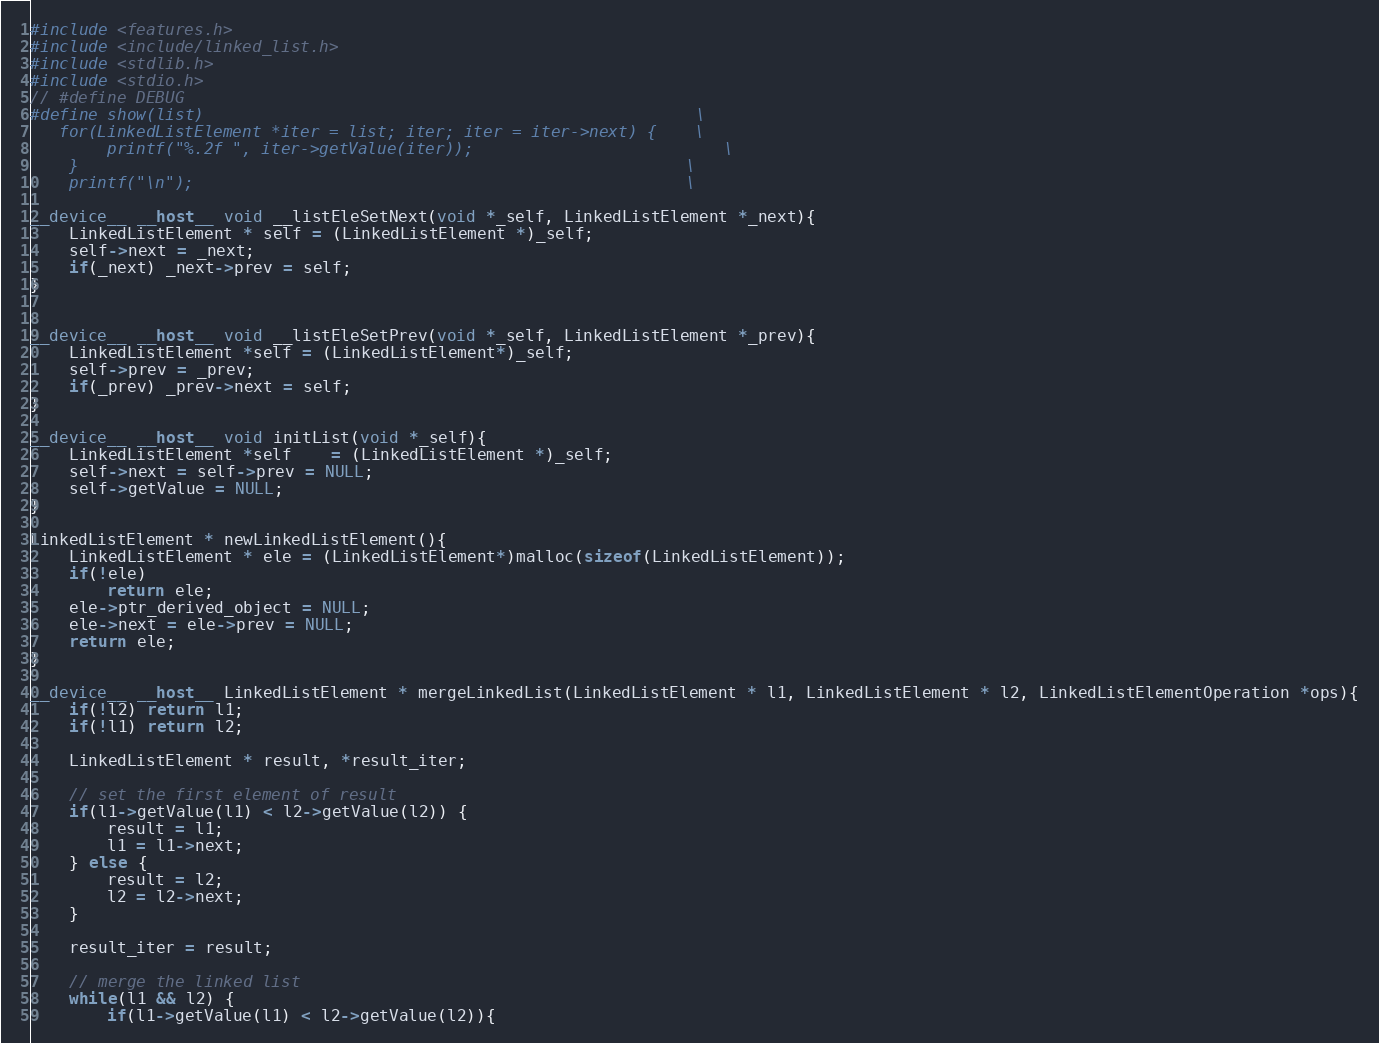Convert code to text. <code><loc_0><loc_0><loc_500><loc_500><_Cuda_>#include <features.h>
#include <include/linked_list.h>
#include <stdlib.h>
#include <stdio.h>
// #define DEBUG
#define show(list) 													\
   for(LinkedListElement *iter = list; iter; iter = iter->next) {    \
		printf("%.2f ", iter->getValue(iter));  						\
	}  																\
	printf("\n"); 													\

__device__ __host__ void __listEleSetNext(void *_self, LinkedListElement *_next){
	LinkedListElement * self = (LinkedListElement *)_self;	
	self->next = _next;
	if(_next) _next->prev = self;
}


__device__ __host__ void __listEleSetPrev(void *_self, LinkedListElement *_prev){
	LinkedListElement *self = (LinkedListElement*)_self;
	self->prev = _prev;
	if(_prev) _prev->next = self;
}

__device__ __host__ void initList(void *_self){
	LinkedListElement *self	= (LinkedListElement *)_self;
	self->next = self->prev = NULL;
	self->getValue = NULL;
}

LinkedListElement * newLinkedListElement(){
	LinkedListElement * ele = (LinkedListElement*)malloc(sizeof(LinkedListElement));
	if(!ele)
		return ele;
	ele->ptr_derived_object = NULL;
    ele->next = ele->prev = NULL;
	return ele;
}

__device__ __host__ LinkedListElement * mergeLinkedList(LinkedListElement * l1, LinkedListElement * l2, LinkedListElementOperation *ops){
	if(!l2) return l1;
	if(!l1) return l2;

	LinkedListElement * result, *result_iter;
	
	// set the first element of result
	if(l1->getValue(l1) < l2->getValue(l2)) {
		result = l1;
		l1 = l1->next;
	} else {
		result = l2;
		l2 = l2->next;
	}
	
	result_iter = result;
	
	// merge the linked list
	while(l1 && l2) {
		if(l1->getValue(l1) < l2->getValue(l2)){</code> 